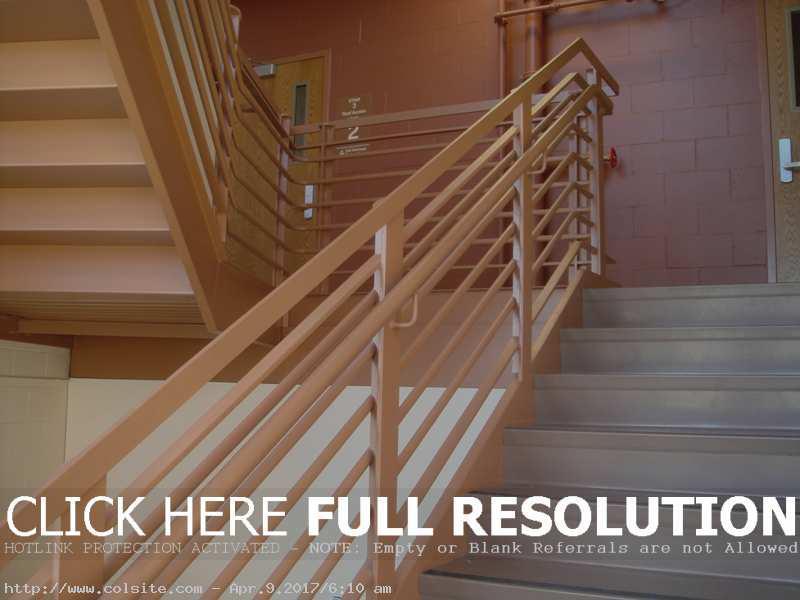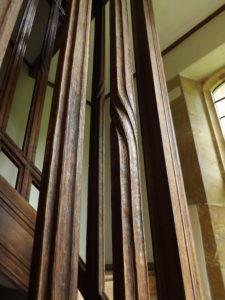The first image is the image on the left, the second image is the image on the right. For the images shown, is this caption "Each staircase has a banister." true? Answer yes or no. No. The first image is the image on the left, the second image is the image on the right. Given the left and right images, does the statement "All of the staircases have vertical banisters for support." hold true? Answer yes or no. No. 